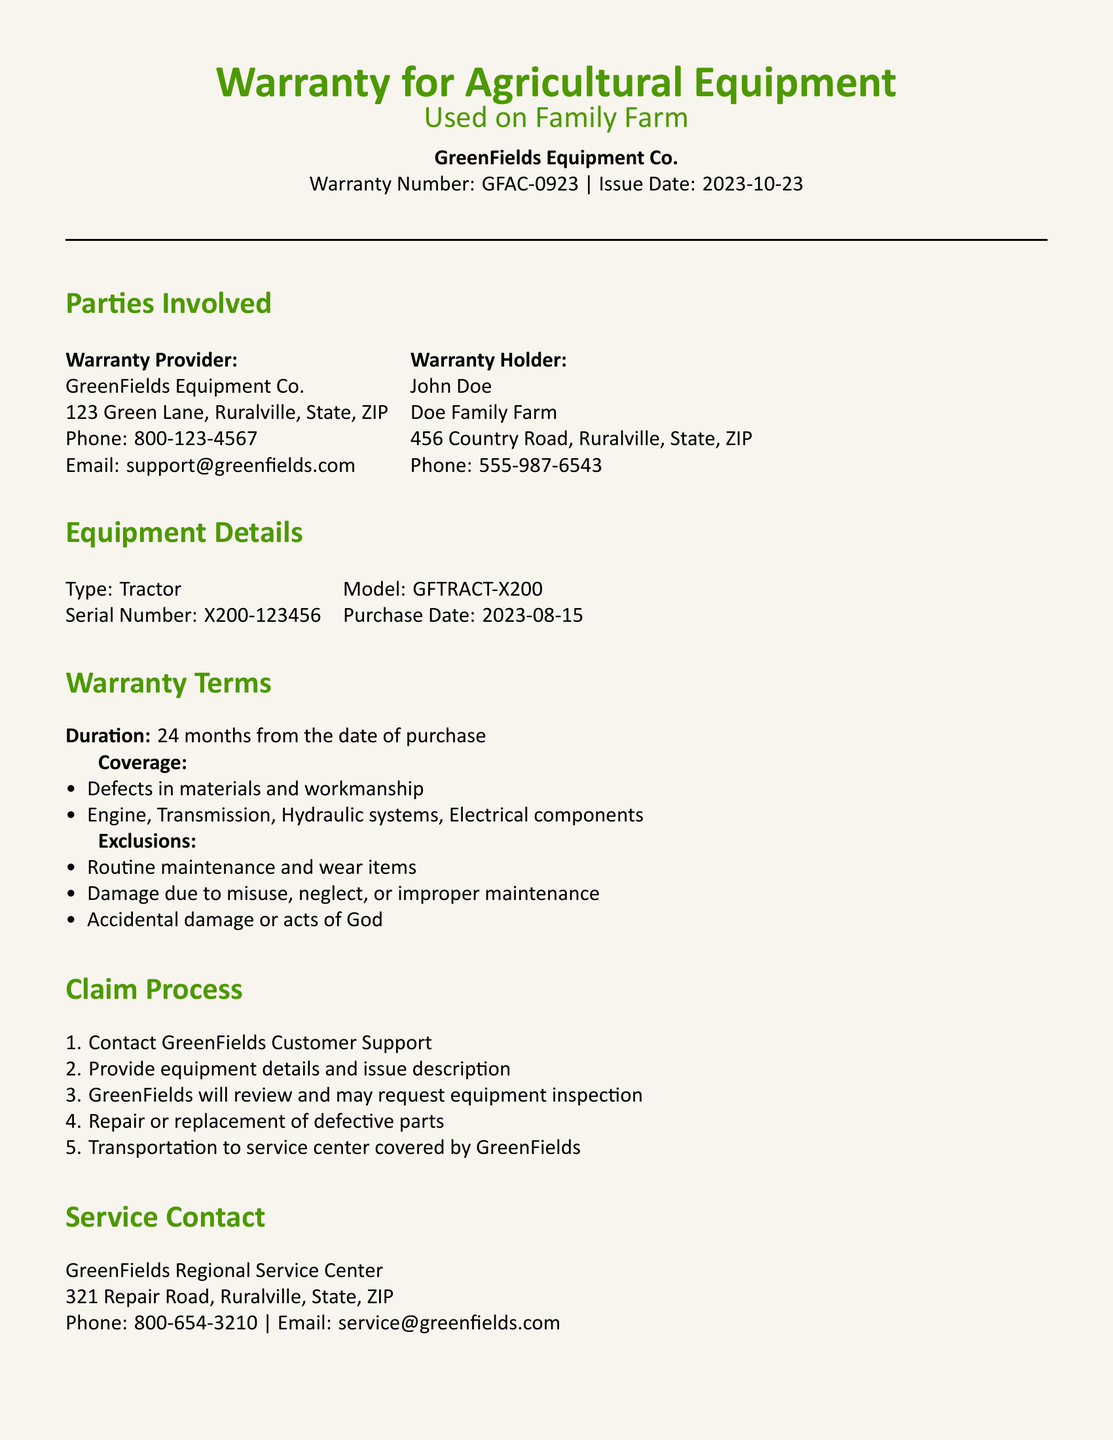What is the warranty number? The warranty number is a unique identifier for the warranty document issued by the provider, which is GFAC-0923.
Answer: GFAC-0923 Who is the warranty provider? The warranty provider is the company that offers the warranty and is responsible for its terms, which is GreenFields Equipment Co.
Answer: GreenFields Equipment Co What is the purchase date of the equipment? The purchase date indicates when the equipment was bought, which is 2023-08-15.
Answer: 2023-08-15 How long is the warranty duration? The warranty duration specifies the period the warranty is valid for, which is 24 months from the date of purchase.
Answer: 24 months What should be included in a warranty claim? Claims must include relevant documentation to validate the purchase and warranty coverage, which is original purchase documentation.
Answer: Original purchase documentation What types of damages are excluded from the warranty coverage? Exclusions detail situations that are not covered by the warranty, such as damage due to misuse, neglect, or improper maintenance.
Answer: Misuse, neglect, or improper maintenance Can the warranty be transferred to a new owner? The transferability of the warranty specifies whether it can be passed on to someone else, which is yes if sold within the warranty period.
Answer: Yes What is the service contact phone number? The service contact phone number allows the warranty holder to reach the provider for assistance, which is 800-654-3210.
Answer: 800-654-3210 